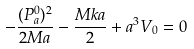<formula> <loc_0><loc_0><loc_500><loc_500>- \frac { ( P _ { a } ^ { 0 } ) ^ { 2 } } { 2 M a } - \frac { M k a } { 2 } + a ^ { 3 } V _ { 0 } = 0</formula> 